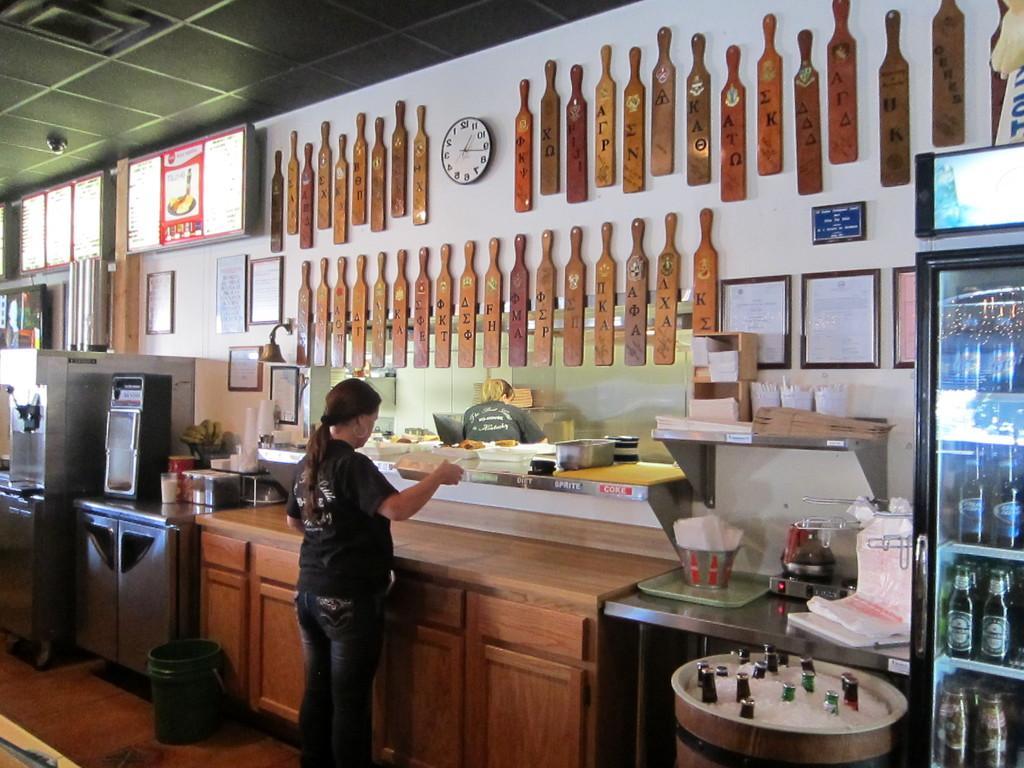Can you describe this image briefly? There is a woman in the picture standing in front of a desk. There are some kitchen accessories on the table. There are some photographs and hangers attached to the wall. We can observe wall clock here. In the right side there is a refrigerator in which some drinks were placed. 